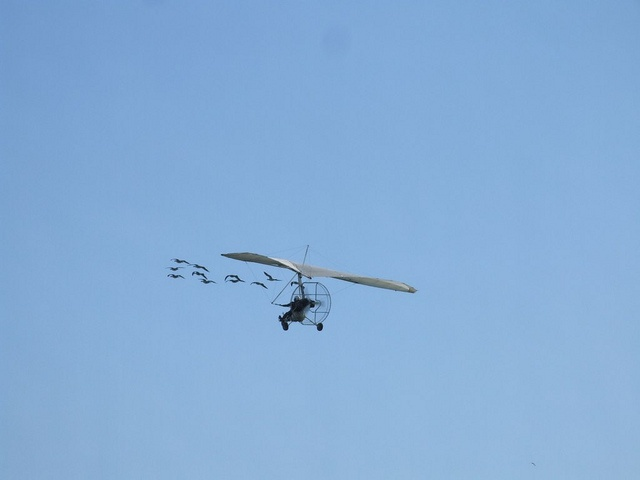Describe the objects in this image and their specific colors. I can see people in darkgray, black, navy, and blue tones, bird in darkgray, lightblue, and gray tones, bird in darkgray, lightblue, darkblue, and gray tones, bird in darkgray, lightblue, blue, gray, and navy tones, and bird in darkgray, lightblue, navy, gray, and blue tones in this image. 